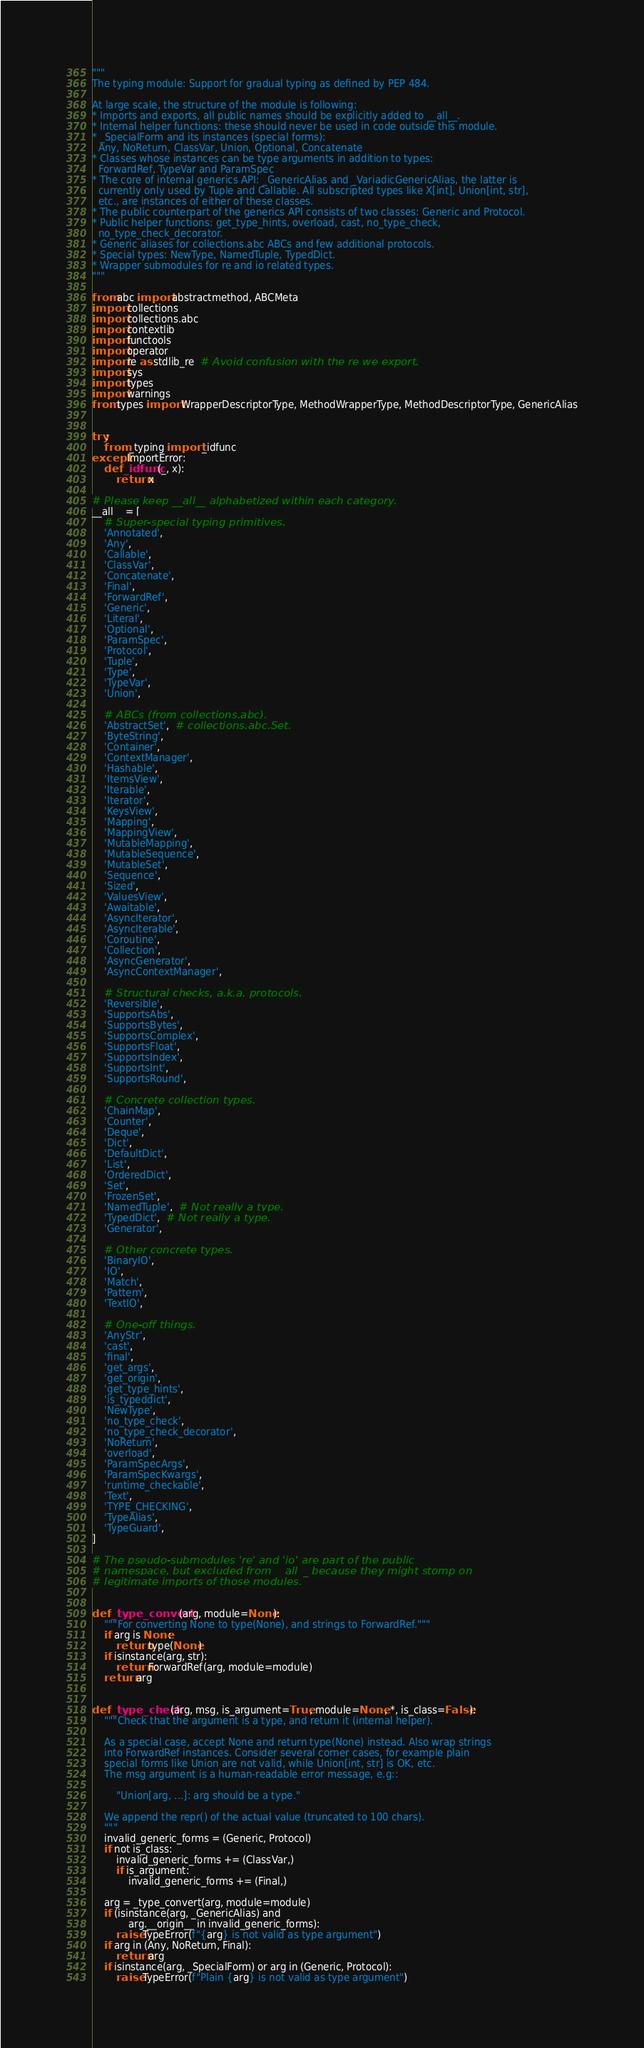Convert code to text. <code><loc_0><loc_0><loc_500><loc_500><_Python_>"""
The typing module: Support for gradual typing as defined by PEP 484.

At large scale, the structure of the module is following:
* Imports and exports, all public names should be explicitly added to __all__.
* Internal helper functions: these should never be used in code outside this module.
* _SpecialForm and its instances (special forms):
  Any, NoReturn, ClassVar, Union, Optional, Concatenate
* Classes whose instances can be type arguments in addition to types:
  ForwardRef, TypeVar and ParamSpec
* The core of internal generics API: _GenericAlias and _VariadicGenericAlias, the latter is
  currently only used by Tuple and Callable. All subscripted types like X[int], Union[int, str],
  etc., are instances of either of these classes.
* The public counterpart of the generics API consists of two classes: Generic and Protocol.
* Public helper functions: get_type_hints, overload, cast, no_type_check,
  no_type_check_decorator.
* Generic aliases for collections.abc ABCs and few additional protocols.
* Special types: NewType, NamedTuple, TypedDict.
* Wrapper submodules for re and io related types.
"""

from abc import abstractmethod, ABCMeta
import collections
import collections.abc
import contextlib
import functools
import operator
import re as stdlib_re  # Avoid confusion with the re we export.
import sys
import types
import warnings
from types import WrapperDescriptorType, MethodWrapperType, MethodDescriptorType, GenericAlias


try:
    from _typing import _idfunc
except ImportError:
    def _idfunc(_, x):
        return x

# Please keep __all__ alphabetized within each category.
__all__ = [
    # Super-special typing primitives.
    'Annotated',
    'Any',
    'Callable',
    'ClassVar',
    'Concatenate',
    'Final',
    'ForwardRef',
    'Generic',
    'Literal',
    'Optional',
    'ParamSpec',
    'Protocol',
    'Tuple',
    'Type',
    'TypeVar',
    'Union',

    # ABCs (from collections.abc).
    'AbstractSet',  # collections.abc.Set.
    'ByteString',
    'Container',
    'ContextManager',
    'Hashable',
    'ItemsView',
    'Iterable',
    'Iterator',
    'KeysView',
    'Mapping',
    'MappingView',
    'MutableMapping',
    'MutableSequence',
    'MutableSet',
    'Sequence',
    'Sized',
    'ValuesView',
    'Awaitable',
    'AsyncIterator',
    'AsyncIterable',
    'Coroutine',
    'Collection',
    'AsyncGenerator',
    'AsyncContextManager',

    # Structural checks, a.k.a. protocols.
    'Reversible',
    'SupportsAbs',
    'SupportsBytes',
    'SupportsComplex',
    'SupportsFloat',
    'SupportsIndex',
    'SupportsInt',
    'SupportsRound',

    # Concrete collection types.
    'ChainMap',
    'Counter',
    'Deque',
    'Dict',
    'DefaultDict',
    'List',
    'OrderedDict',
    'Set',
    'FrozenSet',
    'NamedTuple',  # Not really a type.
    'TypedDict',  # Not really a type.
    'Generator',

    # Other concrete types.
    'BinaryIO',
    'IO',
    'Match',
    'Pattern',
    'TextIO',

    # One-off things.
    'AnyStr',
    'cast',
    'final',
    'get_args',
    'get_origin',
    'get_type_hints',
    'is_typeddict',
    'NewType',
    'no_type_check',
    'no_type_check_decorator',
    'NoReturn',
    'overload',
    'ParamSpecArgs',
    'ParamSpecKwargs',
    'runtime_checkable',
    'Text',
    'TYPE_CHECKING',
    'TypeAlias',
    'TypeGuard',
]

# The pseudo-submodules 're' and 'io' are part of the public
# namespace, but excluded from __all__ because they might stomp on
# legitimate imports of those modules.


def _type_convert(arg, module=None):
    """For converting None to type(None), and strings to ForwardRef."""
    if arg is None:
        return type(None)
    if isinstance(arg, str):
        return ForwardRef(arg, module=module)
    return arg


def _type_check(arg, msg, is_argument=True, module=None, *, is_class=False):
    """Check that the argument is a type, and return it (internal helper).

    As a special case, accept None and return type(None) instead. Also wrap strings
    into ForwardRef instances. Consider several corner cases, for example plain
    special forms like Union are not valid, while Union[int, str] is OK, etc.
    The msg argument is a human-readable error message, e.g::

        "Union[arg, ...]: arg should be a type."

    We append the repr() of the actual value (truncated to 100 chars).
    """
    invalid_generic_forms = (Generic, Protocol)
    if not is_class:
        invalid_generic_forms += (ClassVar,)
        if is_argument:
            invalid_generic_forms += (Final,)

    arg = _type_convert(arg, module=module)
    if (isinstance(arg, _GenericAlias) and
            arg.__origin__ in invalid_generic_forms):
        raise TypeError(f"{arg} is not valid as type argument")
    if arg in (Any, NoReturn, Final):
        return arg
    if isinstance(arg, _SpecialForm) or arg in (Generic, Protocol):
        raise TypeError(f"Plain {arg} is not valid as type argument")</code> 